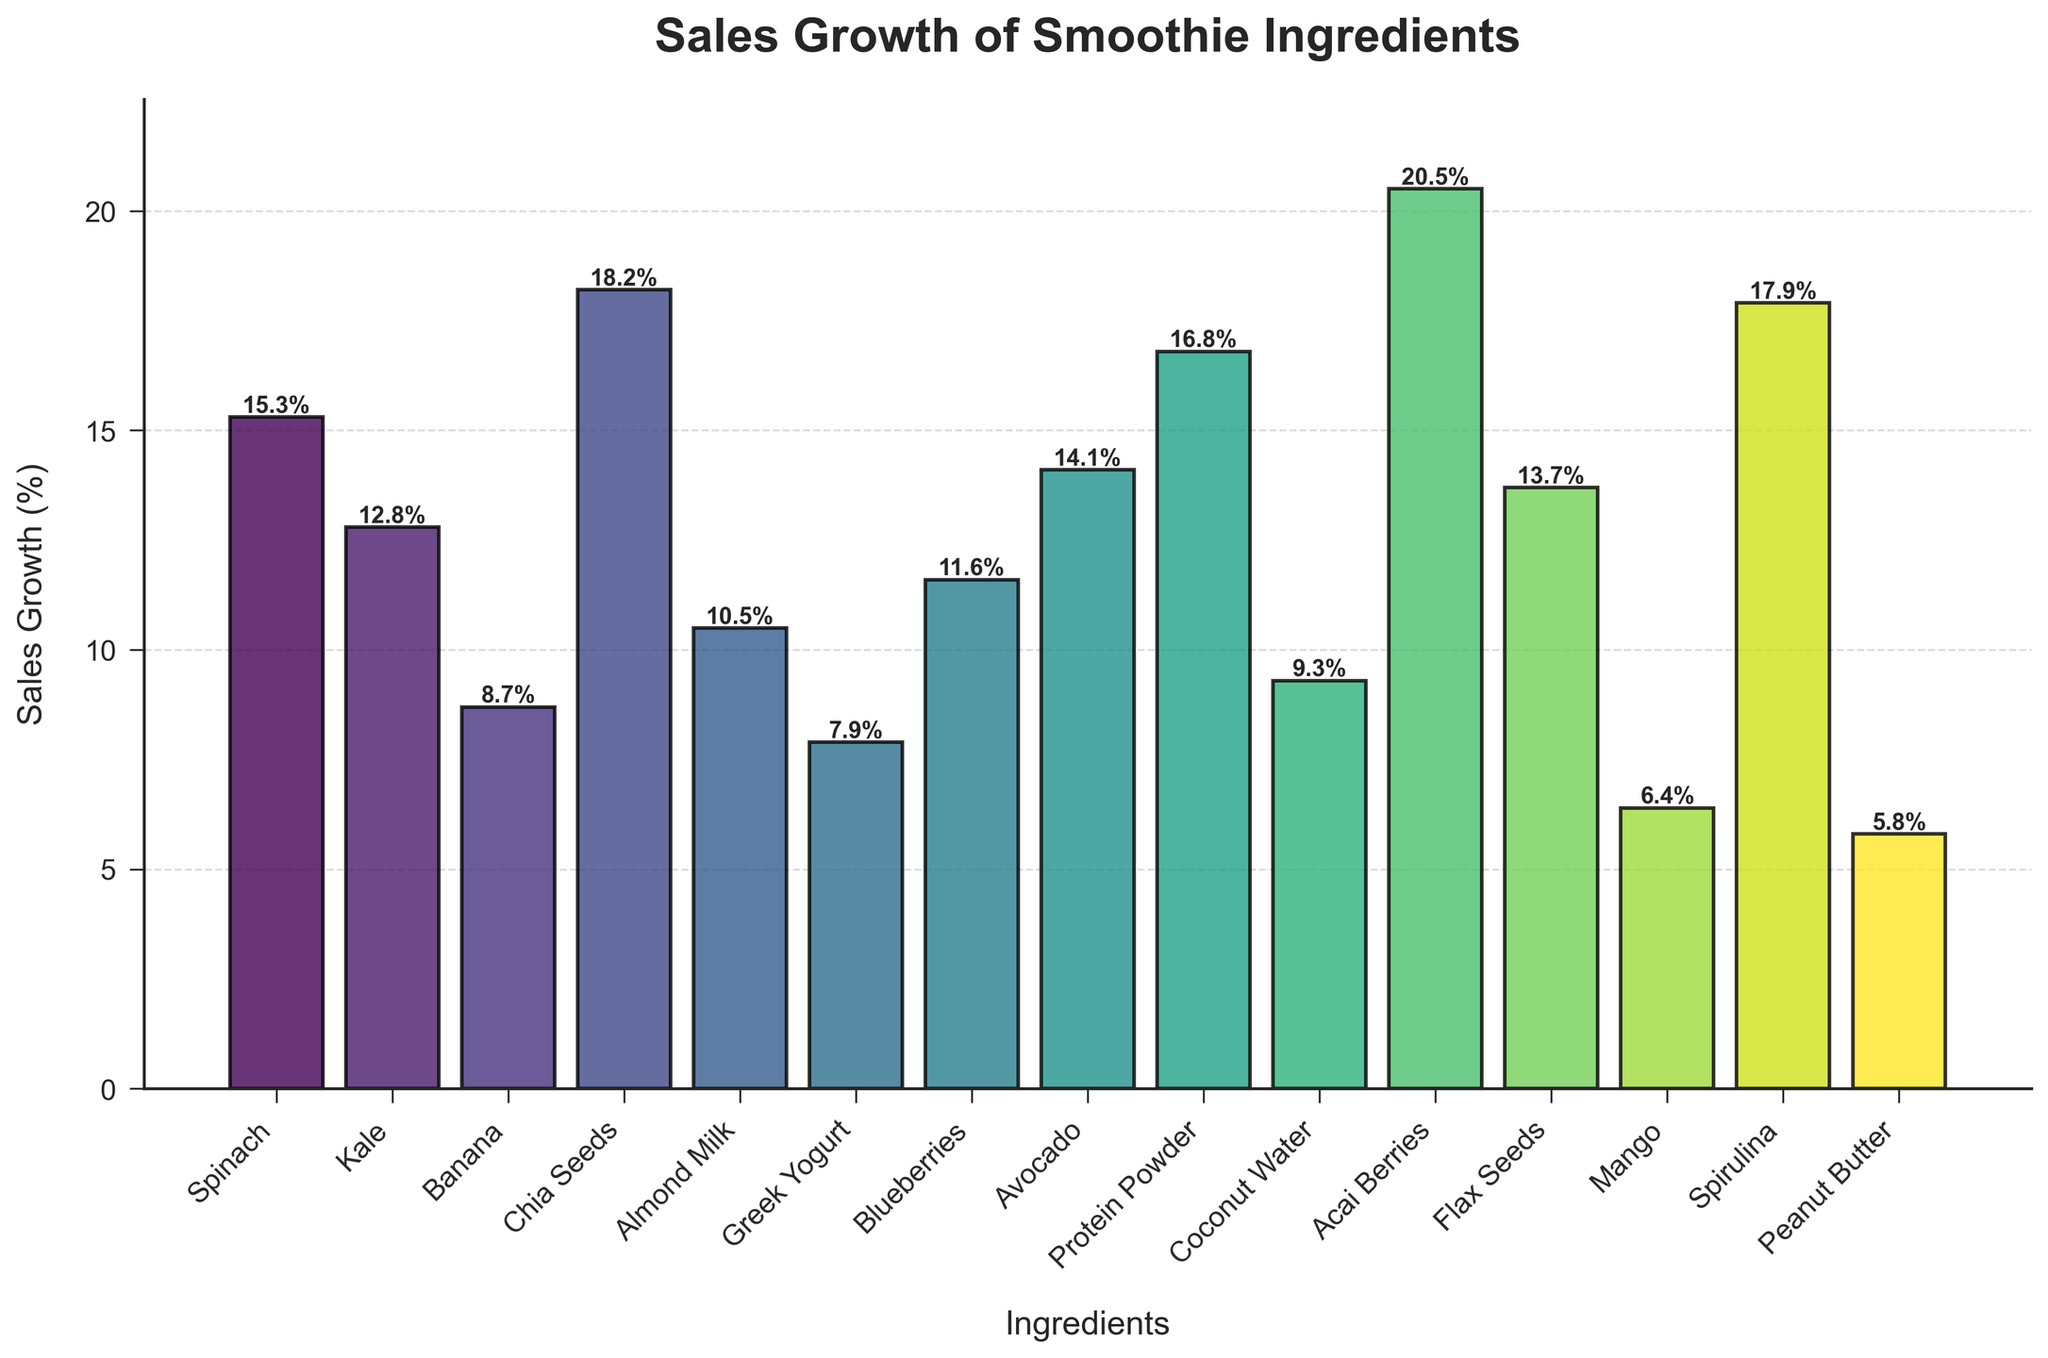What ingredient has the highest sales growth? The tallest bar in the bar chart represents the ingredient with the highest sales growth. The tallest bar corresponds to Acai Berries.
Answer: Acai Berries How much more is the sales growth of Chia Seeds compared to Greek Yogurt? To find this, locate the bars for Chia Seeds and Greek Yogurt. Chia Seeds have a growth of 18.2%, and Greek Yogurt has 7.9%. Subtract 7.9% from 18.2%.
Answer: 10.3% Which ingredient has the lowest sales growth? The shortest bar in the bar chart represents the ingredient with the lowest sales growth. The shortest bar corresponds to Peanut Butter.
Answer: Peanut Butter What is the combined sales growth of Spinach, Kale, and Avocado? Locate the bars for Spinach, Kale, and Avocado. Their sales growth are 15.3%, 12.8%, and 14.1%, respectively. Add these values: 15.3 + 12.8 + 14.1 = 42.2%.
Answer: 42.2% Which ingredients have a sales growth percentage greater than 15%? Identify all the bars with heights greater than 15%. These bars represent Acai Berries, Protein Powder, Spirulina, Chia Seeds, Spinach, and Avocado.
Answer: Acai Berries, Protein Powder, Spirulina, Chia Seeds, Spinach, Avocado What is the average sales growth of all ingredients? To find the average, sum up all the sales growth percentages and divide by the number of ingredients. Sum = 15.3 + 12.8 + 8.7 + 18.2 + 10.5 + 7.9 + 11.6 + 14.1 + 16.8 + 9.3 + 20.5 + 13.7 + 6.4 + 17.9 + 5.8 = 189.5%. Number of ingredients = 15. Average = 189.5 / 15 = 12.63%.
Answer: 12.63% Are there more ingredients with a sales growth percentage below or above 10%? Count the bars with heights below 10% and those above 10%. There are 5 ingredients below 10% (Banana, Greek Yogurt, Peanut Butter, Mango, Coconut Water) and 10 above 10%.
Answer: Above 10% How much does the sales growth of Blueberries differ from Protein Powder? Locate the bars for Blueberries and Protein Powder. Blueberries have a sales growth of 11.6%, Protein Powder has 16.8%. Subtract 11.6% from 16.8%.
Answer: 5.2% What is the median sales growth percentage of all the ingredients? To find the median, first list all the sales growth percentages in ascending order: 5.8, 6.4, 7.9, 8.7, 9.3, 10.5, 11.6, 12.8, 13.7, 14.1, 15.3, 16.8, 17.9, 18.2, 20.5. The middle value in this 15-item list is 12.8%.
Answer: 12.8% Which ingredient(s) have sales growth within +/- 2% of the average sales growth? First, find the average sales growth = 12.63%. Now, check which ingredients have sales growth within the range (12.63% - 2% to 12.63% + 2%), i.e., 10.63% to 14.63%. These ingredients are Kale, Blueberries, Flax Seeds, and Avocado.
Answer: Kale, Blueberries, Flax Seeds, Avocado 